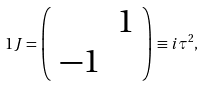Convert formula to latex. <formula><loc_0><loc_0><loc_500><loc_500>1 J = \left ( \begin{array} { c c } & 1 \\ - 1 & \end{array} \right ) \equiv i \tau ^ { 2 } ,</formula> 